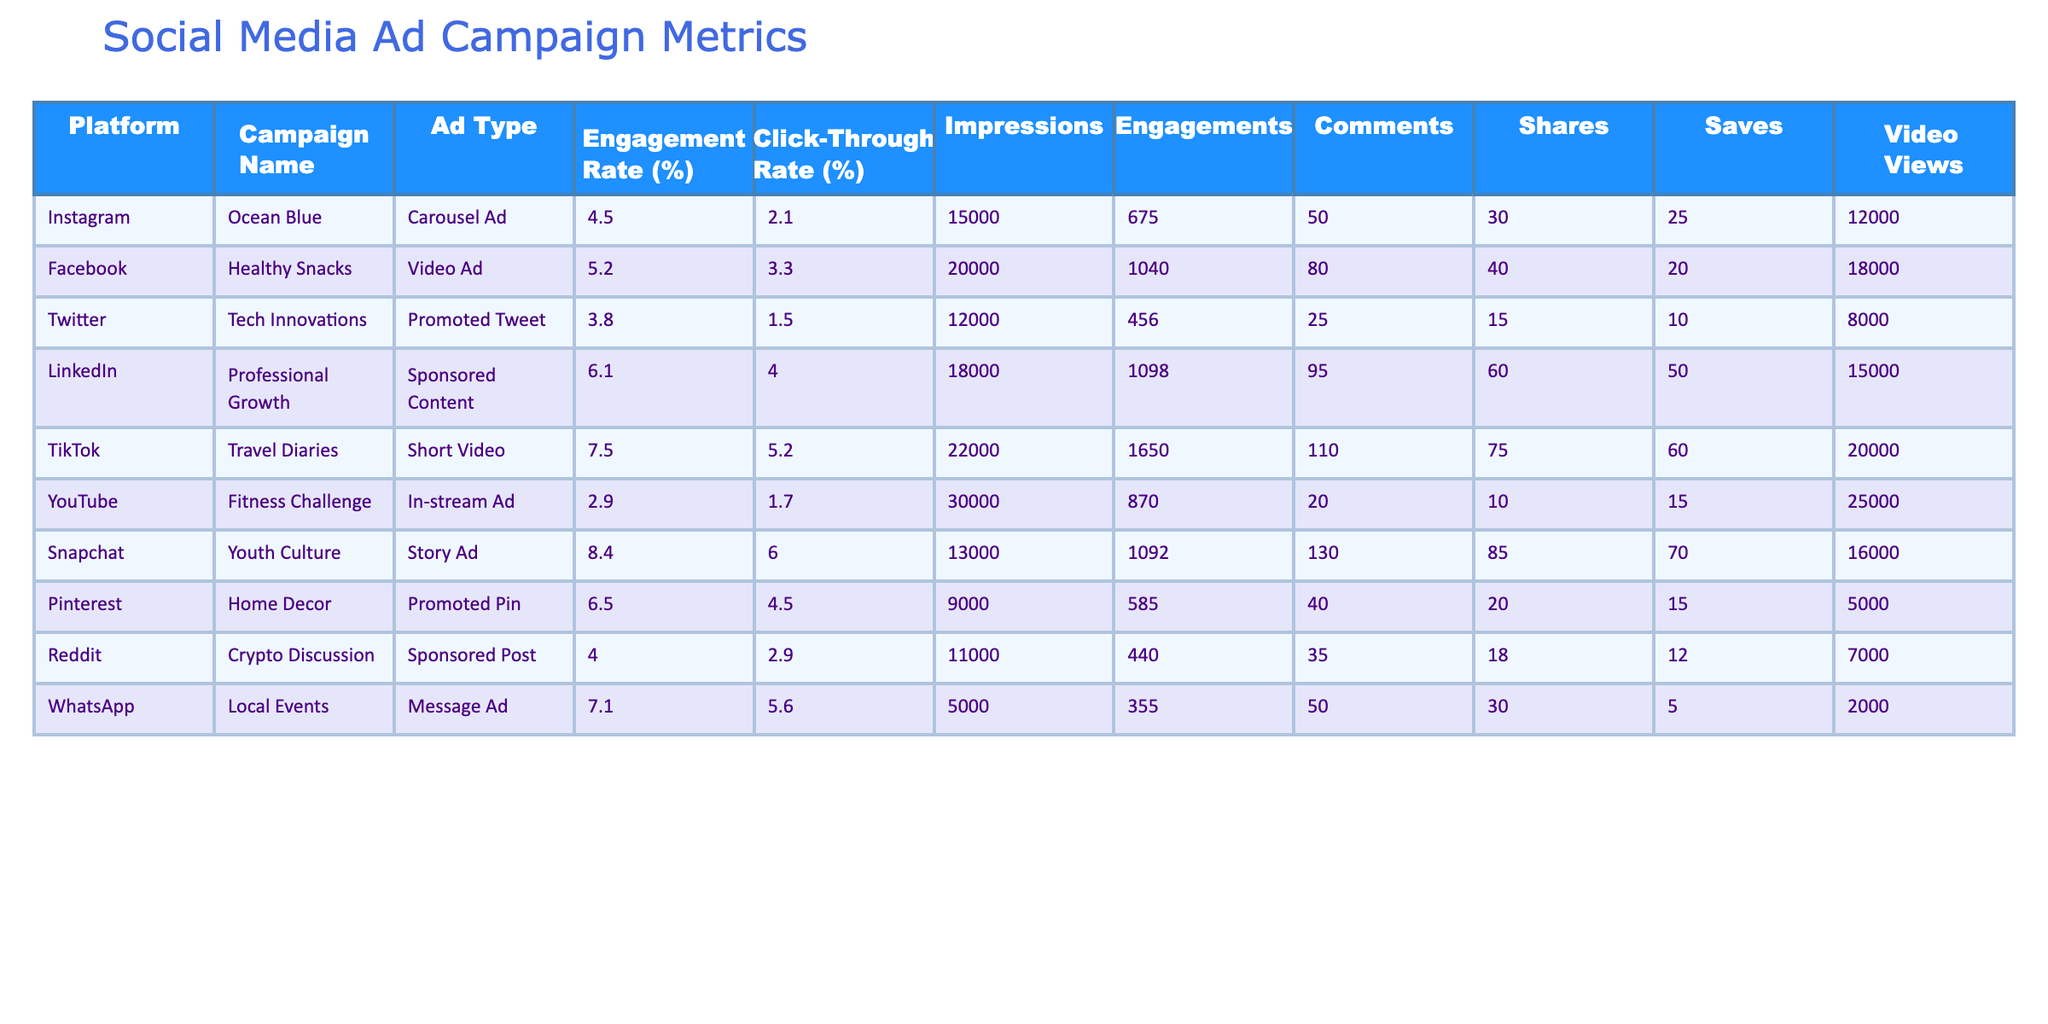What is the highest engagement rate among the campaigns? Reviewing the engagement rates listed for each campaign, the highest engagement rate is found in the TikTok campaign "Travel Diaries," which has an engagement rate of 7.5%.
Answer: 7.5% Which platform had the most video views? The "YouTube, Fitness Challenge" campaign had the most video views at 25,000, making it the campaign with the highest video views across all platforms.
Answer: 25000 Calculate the average click-through rate of all campaigns. First, I will sum up the click-through rates: (2.1 + 3.3 + 1.5 + 4.0 + 5.2 + 1.7 + 6.0 + 4.5 + 2.9 + 5.6) = 31.8. Next, I divide by the number of campaigns (10), resulting in an average click-through rate of 31.8/10 = 3.18%.
Answer: 3.18% Does the Snapchat campaign have a higher engagement rate than the Facebook campaign? The engagement rate for Snapchat's "Youth Culture" campaign is 8.4% while Facebook's "Healthy Snacks" campaign has an engagement rate of 5.2%. Comparing these rates, Snapchat's rate is indeed higher.
Answer: Yes How many engagements did the LinkedIn campaign receive? The LinkedIn campaign named "Professional Growth" received a total of 1,098 engagements as stated in the table.
Answer: 1098 Which ad type had the least number of shares? By comparing the share counts across all ad types, the "YouTube, Fitness Challenge" in-stream ad received only 10 shares, making it the ad type with the least shares.
Answer: 10 Identify which campaign had the lowest impressions. Upon reviewing the impressions for each campaign, the "WhatsApp, Local Events" message ad had the lowest impressions, totaling to 5,000.
Answer: 5000 How many total saves do all campaigns have combined? I will add the number of saves from each campaign: (25+20+10+50+60+15+70+15+12+5) = 327. Thus, the total number of saves from all campaigns combined is 327.
Answer: 327 Is the engagement rate for the "Ocean Blue" campaign lower than the industry average? The engagement rate for the "Ocean Blue" campaign is 4.5%. Assuming an industry average engagement rate is between 5%-6%, it can be concluded that 4.5% is lower than the assumed average.
Answer: Yes 